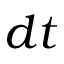<formula> <loc_0><loc_0><loc_500><loc_500>d t</formula> 